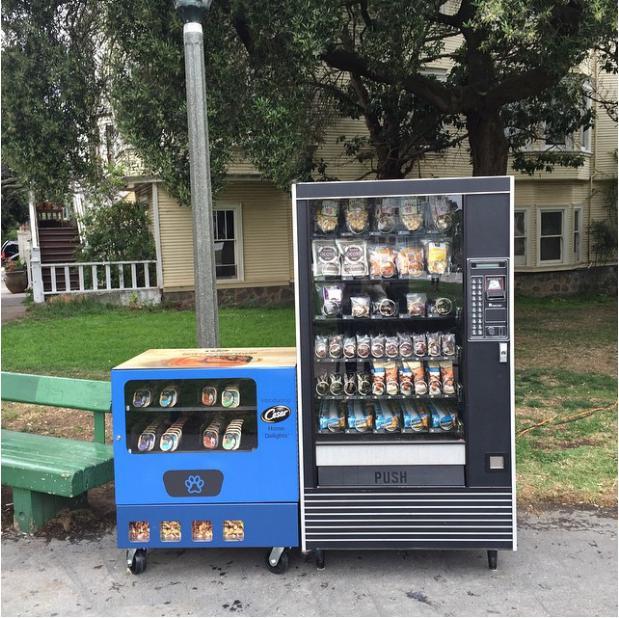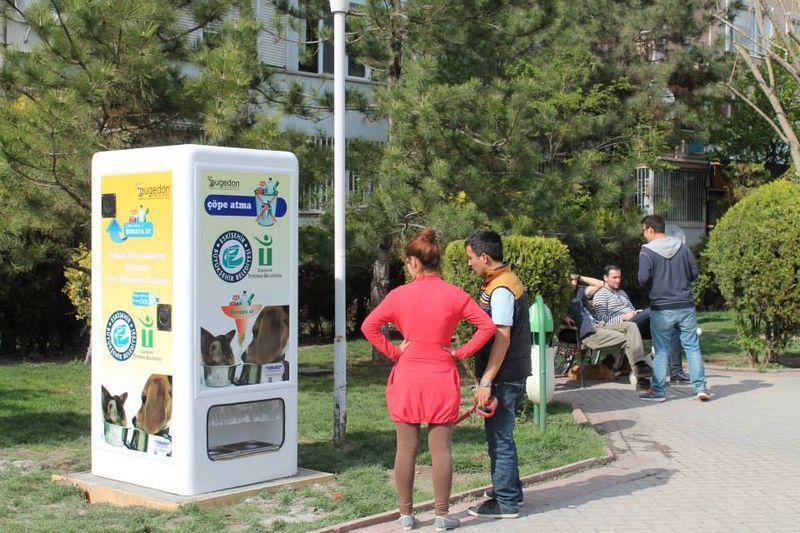The first image is the image on the left, the second image is the image on the right. Evaluate the accuracy of this statement regarding the images: "In one image, trash containers are sitting beside a vending machine.". Is it true? Answer yes or no. No. The first image is the image on the left, the second image is the image on the right. For the images displayed, is the sentence "One image contains exactly one red vending machine." factually correct? Answer yes or no. No. 